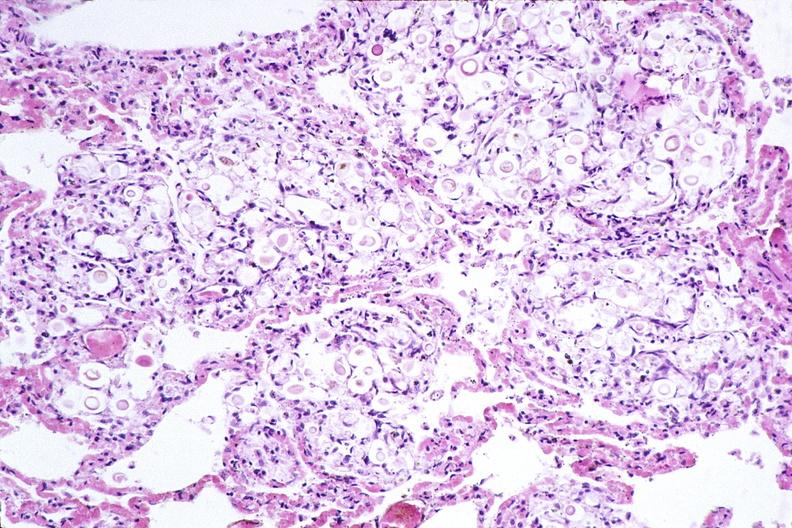where is this?
Answer the question using a single word or phrase. Lung 